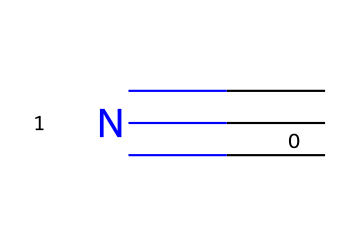What is the molecular formula of this compound? The chemical shown has a carbon atom (C) and a nitrogen atom (N). Counting these gives a total of two atoms, leading to the molecular formula of CN.
Answer: CN How many bonds are present in this molecule? The structure indicates a triple bond between the carbon atom and the nitrogen atom as represented by the "#" symbol in the SMILES notation. Hence, there is one triple bond in the molecule.
Answer: 1 What is the main functional group present in this compound? The presence of the cyano group (C≡N) indicates that this compound is a nitrile, characterized specifically by the carbon atom forming a triple bond with the nitrogen atom.
Answer: nitrile What type of hybridization is associated with the carbon atom in this compound? The carbon atom in a nitrile is involved in a triple bond, which generally involves sp hybridization. The carbon atom is bonded to the nitrogen atom in such a way that it requires two p orbitals and one s orbital for bonding.
Answer: sp Is this compound polar or nonpolar? The polarity of this molecule is determined by the difference in electronegativity between carbon and nitrogen. Since nitrogen is more electronegative, the molecule has polar characteristics; however, the linear shape results in overall nonpolarity.
Answer: nonpolar What is the main use of hydrogen cyanide? Hydrogen cyanide, which this structure represents, is primarily utilized in organic synthesis and as a precursor in the production of plastics and pesticides, noted for its high toxicity as well.
Answer: synthetic chemical 